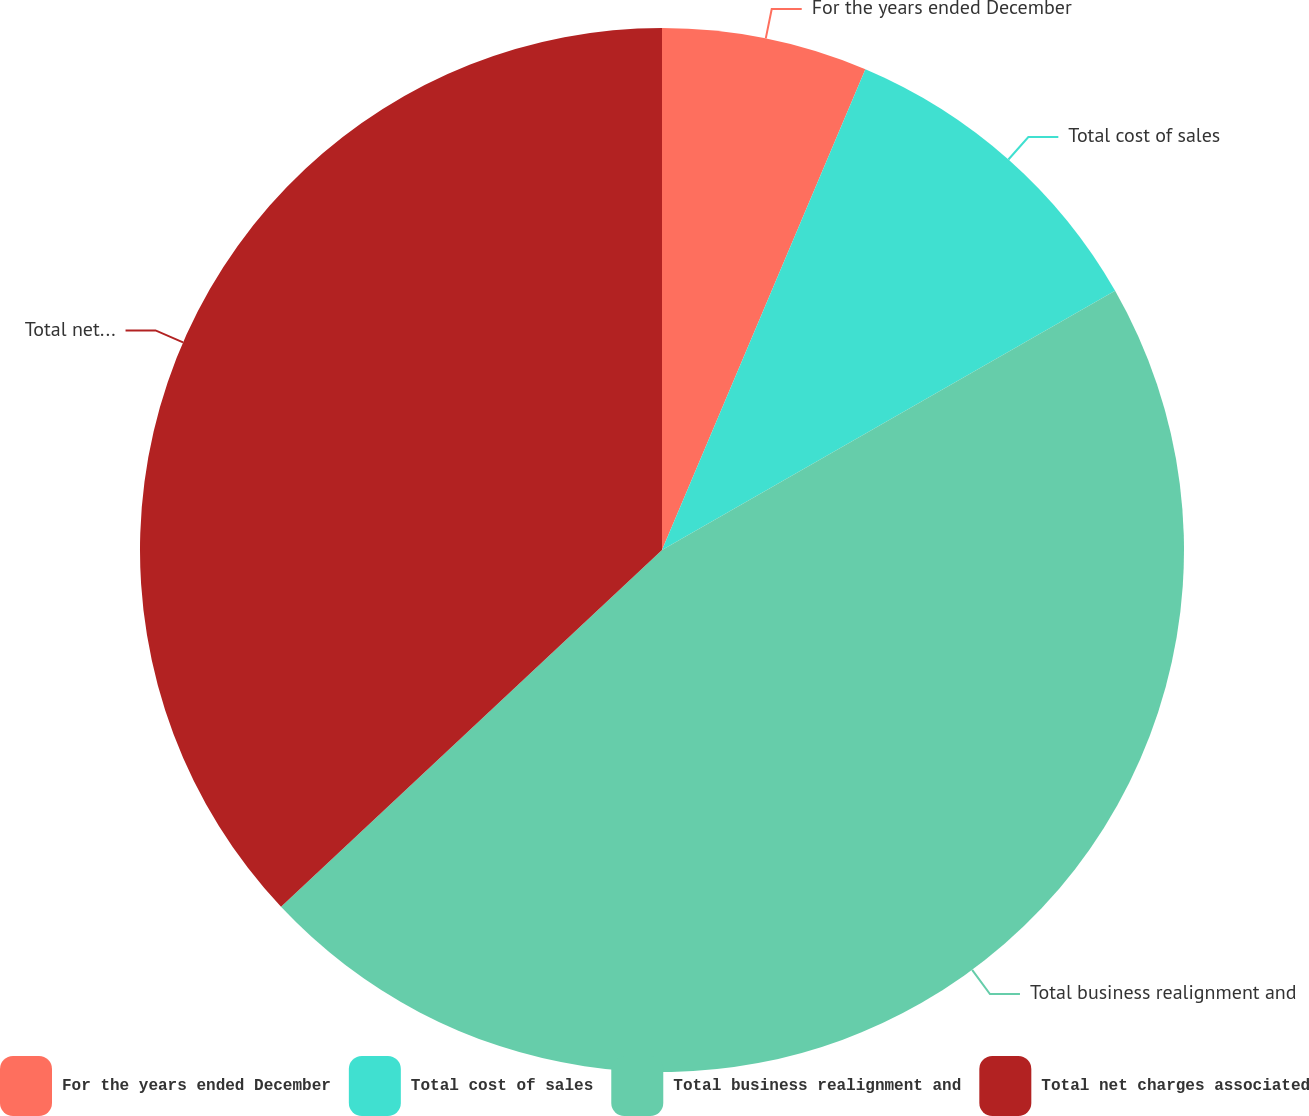Convert chart. <chart><loc_0><loc_0><loc_500><loc_500><pie_chart><fcel>For the years ended December<fcel>Total cost of sales<fcel>Total business realignment and<fcel>Total net charges associated<nl><fcel>6.37%<fcel>10.36%<fcel>46.29%<fcel>36.98%<nl></chart> 